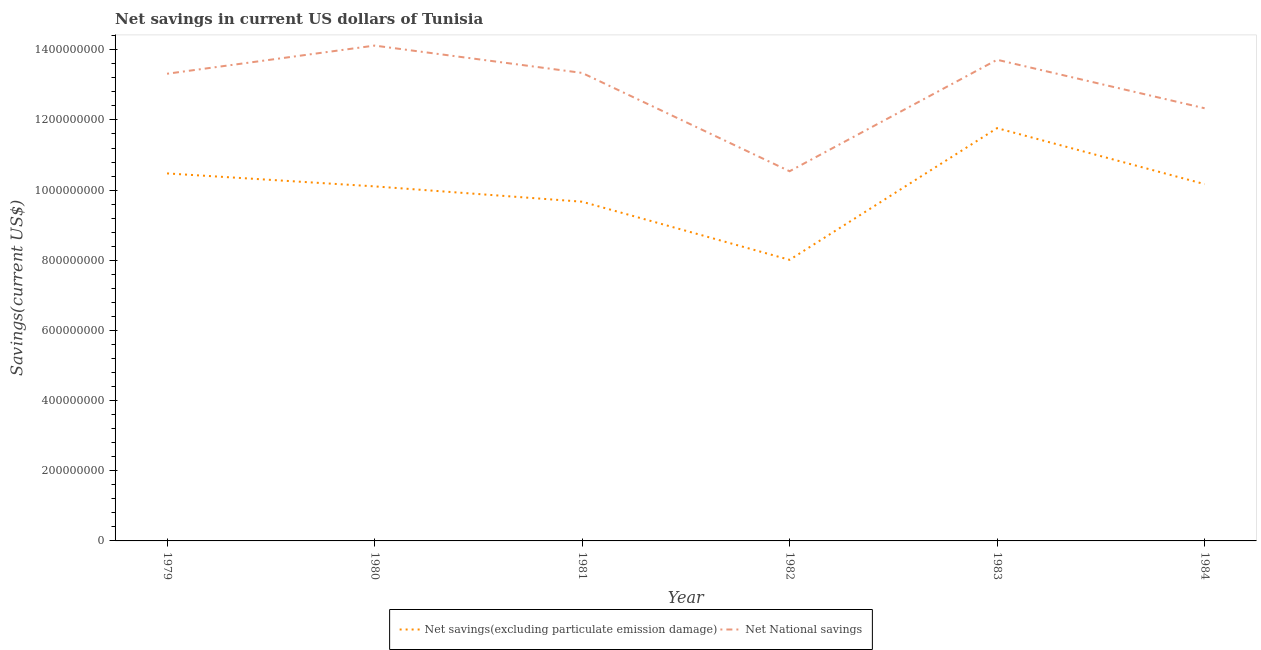How many different coloured lines are there?
Your answer should be very brief. 2. Is the number of lines equal to the number of legend labels?
Your answer should be very brief. Yes. What is the net savings(excluding particulate emission damage) in 1979?
Keep it short and to the point. 1.05e+09. Across all years, what is the maximum net savings(excluding particulate emission damage)?
Your response must be concise. 1.18e+09. Across all years, what is the minimum net national savings?
Make the answer very short. 1.05e+09. In which year was the net national savings maximum?
Ensure brevity in your answer.  1980. What is the total net national savings in the graph?
Provide a short and direct response. 7.74e+09. What is the difference between the net national savings in 1981 and that in 1984?
Offer a terse response. 1.01e+08. What is the difference between the net national savings in 1982 and the net savings(excluding particulate emission damage) in 1984?
Offer a terse response. 3.68e+07. What is the average net savings(excluding particulate emission damage) per year?
Your answer should be compact. 1.00e+09. In the year 1984, what is the difference between the net savings(excluding particulate emission damage) and net national savings?
Give a very brief answer. -2.16e+08. What is the ratio of the net savings(excluding particulate emission damage) in 1981 to that in 1984?
Ensure brevity in your answer.  0.95. Is the net savings(excluding particulate emission damage) in 1980 less than that in 1982?
Provide a succinct answer. No. Is the difference between the net savings(excluding particulate emission damage) in 1980 and 1982 greater than the difference between the net national savings in 1980 and 1982?
Keep it short and to the point. No. What is the difference between the highest and the second highest net national savings?
Your answer should be compact. 4.04e+07. What is the difference between the highest and the lowest net national savings?
Offer a very short reply. 3.58e+08. Is the net national savings strictly greater than the net savings(excluding particulate emission damage) over the years?
Provide a short and direct response. Yes. Is the net national savings strictly less than the net savings(excluding particulate emission damage) over the years?
Offer a terse response. No. How many lines are there?
Give a very brief answer. 2. How many years are there in the graph?
Keep it short and to the point. 6. What is the difference between two consecutive major ticks on the Y-axis?
Provide a succinct answer. 2.00e+08. Are the values on the major ticks of Y-axis written in scientific E-notation?
Your response must be concise. No. Does the graph contain any zero values?
Your answer should be very brief. No. Does the graph contain grids?
Your response must be concise. No. Where does the legend appear in the graph?
Offer a terse response. Bottom center. How are the legend labels stacked?
Offer a very short reply. Horizontal. What is the title of the graph?
Your response must be concise. Net savings in current US dollars of Tunisia. Does "Formally registered" appear as one of the legend labels in the graph?
Your answer should be very brief. No. What is the label or title of the Y-axis?
Offer a terse response. Savings(current US$). What is the Savings(current US$) of Net savings(excluding particulate emission damage) in 1979?
Make the answer very short. 1.05e+09. What is the Savings(current US$) of Net National savings in 1979?
Make the answer very short. 1.33e+09. What is the Savings(current US$) of Net savings(excluding particulate emission damage) in 1980?
Provide a succinct answer. 1.01e+09. What is the Savings(current US$) of Net National savings in 1980?
Keep it short and to the point. 1.41e+09. What is the Savings(current US$) of Net savings(excluding particulate emission damage) in 1981?
Your answer should be very brief. 9.67e+08. What is the Savings(current US$) in Net National savings in 1981?
Give a very brief answer. 1.33e+09. What is the Savings(current US$) in Net savings(excluding particulate emission damage) in 1982?
Ensure brevity in your answer.  8.01e+08. What is the Savings(current US$) of Net National savings in 1982?
Ensure brevity in your answer.  1.05e+09. What is the Savings(current US$) of Net savings(excluding particulate emission damage) in 1983?
Provide a short and direct response. 1.18e+09. What is the Savings(current US$) in Net National savings in 1983?
Offer a very short reply. 1.37e+09. What is the Savings(current US$) in Net savings(excluding particulate emission damage) in 1984?
Your answer should be very brief. 1.02e+09. What is the Savings(current US$) in Net National savings in 1984?
Ensure brevity in your answer.  1.23e+09. Across all years, what is the maximum Savings(current US$) in Net savings(excluding particulate emission damage)?
Your answer should be very brief. 1.18e+09. Across all years, what is the maximum Savings(current US$) in Net National savings?
Ensure brevity in your answer.  1.41e+09. Across all years, what is the minimum Savings(current US$) in Net savings(excluding particulate emission damage)?
Provide a succinct answer. 8.01e+08. Across all years, what is the minimum Savings(current US$) of Net National savings?
Your answer should be compact. 1.05e+09. What is the total Savings(current US$) of Net savings(excluding particulate emission damage) in the graph?
Your response must be concise. 6.02e+09. What is the total Savings(current US$) in Net National savings in the graph?
Provide a short and direct response. 7.74e+09. What is the difference between the Savings(current US$) in Net savings(excluding particulate emission damage) in 1979 and that in 1980?
Offer a very short reply. 3.70e+07. What is the difference between the Savings(current US$) in Net National savings in 1979 and that in 1980?
Offer a very short reply. -8.03e+07. What is the difference between the Savings(current US$) of Net savings(excluding particulate emission damage) in 1979 and that in 1981?
Give a very brief answer. 8.07e+07. What is the difference between the Savings(current US$) of Net National savings in 1979 and that in 1981?
Give a very brief answer. -2.39e+06. What is the difference between the Savings(current US$) of Net savings(excluding particulate emission damage) in 1979 and that in 1982?
Provide a short and direct response. 2.46e+08. What is the difference between the Savings(current US$) of Net National savings in 1979 and that in 1982?
Provide a short and direct response. 2.78e+08. What is the difference between the Savings(current US$) in Net savings(excluding particulate emission damage) in 1979 and that in 1983?
Your answer should be compact. -1.29e+08. What is the difference between the Savings(current US$) in Net National savings in 1979 and that in 1983?
Your answer should be very brief. -3.99e+07. What is the difference between the Savings(current US$) of Net savings(excluding particulate emission damage) in 1979 and that in 1984?
Ensure brevity in your answer.  3.06e+07. What is the difference between the Savings(current US$) in Net National savings in 1979 and that in 1984?
Offer a terse response. 9.84e+07. What is the difference between the Savings(current US$) of Net savings(excluding particulate emission damage) in 1980 and that in 1981?
Your answer should be very brief. 4.37e+07. What is the difference between the Savings(current US$) in Net National savings in 1980 and that in 1981?
Ensure brevity in your answer.  7.79e+07. What is the difference between the Savings(current US$) in Net savings(excluding particulate emission damage) in 1980 and that in 1982?
Provide a short and direct response. 2.09e+08. What is the difference between the Savings(current US$) of Net National savings in 1980 and that in 1982?
Offer a very short reply. 3.58e+08. What is the difference between the Savings(current US$) in Net savings(excluding particulate emission damage) in 1980 and that in 1983?
Provide a short and direct response. -1.66e+08. What is the difference between the Savings(current US$) of Net National savings in 1980 and that in 1983?
Offer a terse response. 4.04e+07. What is the difference between the Savings(current US$) in Net savings(excluding particulate emission damage) in 1980 and that in 1984?
Provide a succinct answer. -6.39e+06. What is the difference between the Savings(current US$) of Net National savings in 1980 and that in 1984?
Provide a short and direct response. 1.79e+08. What is the difference between the Savings(current US$) in Net savings(excluding particulate emission damage) in 1981 and that in 1982?
Offer a very short reply. 1.66e+08. What is the difference between the Savings(current US$) in Net National savings in 1981 and that in 1982?
Give a very brief answer. 2.80e+08. What is the difference between the Savings(current US$) in Net savings(excluding particulate emission damage) in 1981 and that in 1983?
Your answer should be compact. -2.10e+08. What is the difference between the Savings(current US$) in Net National savings in 1981 and that in 1983?
Make the answer very short. -3.75e+07. What is the difference between the Savings(current US$) in Net savings(excluding particulate emission damage) in 1981 and that in 1984?
Offer a very short reply. -5.01e+07. What is the difference between the Savings(current US$) in Net National savings in 1981 and that in 1984?
Your answer should be compact. 1.01e+08. What is the difference between the Savings(current US$) in Net savings(excluding particulate emission damage) in 1982 and that in 1983?
Keep it short and to the point. -3.75e+08. What is the difference between the Savings(current US$) in Net National savings in 1982 and that in 1983?
Offer a very short reply. -3.18e+08. What is the difference between the Savings(current US$) of Net savings(excluding particulate emission damage) in 1982 and that in 1984?
Offer a very short reply. -2.16e+08. What is the difference between the Savings(current US$) of Net National savings in 1982 and that in 1984?
Make the answer very short. -1.80e+08. What is the difference between the Savings(current US$) of Net savings(excluding particulate emission damage) in 1983 and that in 1984?
Provide a succinct answer. 1.60e+08. What is the difference between the Savings(current US$) of Net National savings in 1983 and that in 1984?
Your answer should be compact. 1.38e+08. What is the difference between the Savings(current US$) of Net savings(excluding particulate emission damage) in 1979 and the Savings(current US$) of Net National savings in 1980?
Provide a succinct answer. -3.64e+08. What is the difference between the Savings(current US$) of Net savings(excluding particulate emission damage) in 1979 and the Savings(current US$) of Net National savings in 1981?
Your response must be concise. -2.86e+08. What is the difference between the Savings(current US$) in Net savings(excluding particulate emission damage) in 1979 and the Savings(current US$) in Net National savings in 1982?
Provide a short and direct response. -6.18e+06. What is the difference between the Savings(current US$) in Net savings(excluding particulate emission damage) in 1979 and the Savings(current US$) in Net National savings in 1983?
Keep it short and to the point. -3.24e+08. What is the difference between the Savings(current US$) in Net savings(excluding particulate emission damage) in 1979 and the Savings(current US$) in Net National savings in 1984?
Offer a very short reply. -1.86e+08. What is the difference between the Savings(current US$) in Net savings(excluding particulate emission damage) in 1980 and the Savings(current US$) in Net National savings in 1981?
Offer a very short reply. -3.23e+08. What is the difference between the Savings(current US$) in Net savings(excluding particulate emission damage) in 1980 and the Savings(current US$) in Net National savings in 1982?
Give a very brief answer. -4.31e+07. What is the difference between the Savings(current US$) in Net savings(excluding particulate emission damage) in 1980 and the Savings(current US$) in Net National savings in 1983?
Provide a short and direct response. -3.61e+08. What is the difference between the Savings(current US$) in Net savings(excluding particulate emission damage) in 1980 and the Savings(current US$) in Net National savings in 1984?
Keep it short and to the point. -2.23e+08. What is the difference between the Savings(current US$) of Net savings(excluding particulate emission damage) in 1981 and the Savings(current US$) of Net National savings in 1982?
Your answer should be very brief. -8.69e+07. What is the difference between the Savings(current US$) in Net savings(excluding particulate emission damage) in 1981 and the Savings(current US$) in Net National savings in 1983?
Offer a terse response. -4.05e+08. What is the difference between the Savings(current US$) in Net savings(excluding particulate emission damage) in 1981 and the Savings(current US$) in Net National savings in 1984?
Provide a short and direct response. -2.66e+08. What is the difference between the Savings(current US$) in Net savings(excluding particulate emission damage) in 1982 and the Savings(current US$) in Net National savings in 1983?
Give a very brief answer. -5.70e+08. What is the difference between the Savings(current US$) in Net savings(excluding particulate emission damage) in 1982 and the Savings(current US$) in Net National savings in 1984?
Give a very brief answer. -4.32e+08. What is the difference between the Savings(current US$) in Net savings(excluding particulate emission damage) in 1983 and the Savings(current US$) in Net National savings in 1984?
Give a very brief answer. -5.67e+07. What is the average Savings(current US$) in Net savings(excluding particulate emission damage) per year?
Your answer should be compact. 1.00e+09. What is the average Savings(current US$) of Net National savings per year?
Ensure brevity in your answer.  1.29e+09. In the year 1979, what is the difference between the Savings(current US$) of Net savings(excluding particulate emission damage) and Savings(current US$) of Net National savings?
Your response must be concise. -2.84e+08. In the year 1980, what is the difference between the Savings(current US$) in Net savings(excluding particulate emission damage) and Savings(current US$) in Net National savings?
Your answer should be very brief. -4.01e+08. In the year 1981, what is the difference between the Savings(current US$) of Net savings(excluding particulate emission damage) and Savings(current US$) of Net National savings?
Give a very brief answer. -3.67e+08. In the year 1982, what is the difference between the Savings(current US$) of Net savings(excluding particulate emission damage) and Savings(current US$) of Net National savings?
Make the answer very short. -2.53e+08. In the year 1983, what is the difference between the Savings(current US$) in Net savings(excluding particulate emission damage) and Savings(current US$) in Net National savings?
Make the answer very short. -1.95e+08. In the year 1984, what is the difference between the Savings(current US$) of Net savings(excluding particulate emission damage) and Savings(current US$) of Net National savings?
Your answer should be very brief. -2.16e+08. What is the ratio of the Savings(current US$) in Net savings(excluding particulate emission damage) in 1979 to that in 1980?
Your answer should be compact. 1.04. What is the ratio of the Savings(current US$) of Net National savings in 1979 to that in 1980?
Make the answer very short. 0.94. What is the ratio of the Savings(current US$) of Net savings(excluding particulate emission damage) in 1979 to that in 1981?
Ensure brevity in your answer.  1.08. What is the ratio of the Savings(current US$) of Net savings(excluding particulate emission damage) in 1979 to that in 1982?
Offer a very short reply. 1.31. What is the ratio of the Savings(current US$) of Net National savings in 1979 to that in 1982?
Make the answer very short. 1.26. What is the ratio of the Savings(current US$) of Net savings(excluding particulate emission damage) in 1979 to that in 1983?
Your answer should be very brief. 0.89. What is the ratio of the Savings(current US$) in Net National savings in 1979 to that in 1983?
Provide a succinct answer. 0.97. What is the ratio of the Savings(current US$) of Net savings(excluding particulate emission damage) in 1979 to that in 1984?
Provide a succinct answer. 1.03. What is the ratio of the Savings(current US$) in Net National savings in 1979 to that in 1984?
Offer a terse response. 1.08. What is the ratio of the Savings(current US$) in Net savings(excluding particulate emission damage) in 1980 to that in 1981?
Keep it short and to the point. 1.05. What is the ratio of the Savings(current US$) in Net National savings in 1980 to that in 1981?
Offer a very short reply. 1.06. What is the ratio of the Savings(current US$) of Net savings(excluding particulate emission damage) in 1980 to that in 1982?
Make the answer very short. 1.26. What is the ratio of the Savings(current US$) in Net National savings in 1980 to that in 1982?
Your answer should be compact. 1.34. What is the ratio of the Savings(current US$) in Net savings(excluding particulate emission damage) in 1980 to that in 1983?
Offer a terse response. 0.86. What is the ratio of the Savings(current US$) in Net National savings in 1980 to that in 1983?
Offer a terse response. 1.03. What is the ratio of the Savings(current US$) in Net savings(excluding particulate emission damage) in 1980 to that in 1984?
Provide a succinct answer. 0.99. What is the ratio of the Savings(current US$) in Net National savings in 1980 to that in 1984?
Make the answer very short. 1.14. What is the ratio of the Savings(current US$) in Net savings(excluding particulate emission damage) in 1981 to that in 1982?
Offer a very short reply. 1.21. What is the ratio of the Savings(current US$) in Net National savings in 1981 to that in 1982?
Ensure brevity in your answer.  1.27. What is the ratio of the Savings(current US$) of Net savings(excluding particulate emission damage) in 1981 to that in 1983?
Provide a succinct answer. 0.82. What is the ratio of the Savings(current US$) of Net National savings in 1981 to that in 1983?
Provide a short and direct response. 0.97. What is the ratio of the Savings(current US$) in Net savings(excluding particulate emission damage) in 1981 to that in 1984?
Your answer should be compact. 0.95. What is the ratio of the Savings(current US$) of Net National savings in 1981 to that in 1984?
Provide a short and direct response. 1.08. What is the ratio of the Savings(current US$) in Net savings(excluding particulate emission damage) in 1982 to that in 1983?
Offer a terse response. 0.68. What is the ratio of the Savings(current US$) in Net National savings in 1982 to that in 1983?
Your answer should be very brief. 0.77. What is the ratio of the Savings(current US$) in Net savings(excluding particulate emission damage) in 1982 to that in 1984?
Your response must be concise. 0.79. What is the ratio of the Savings(current US$) in Net National savings in 1982 to that in 1984?
Make the answer very short. 0.85. What is the ratio of the Savings(current US$) of Net savings(excluding particulate emission damage) in 1983 to that in 1984?
Your response must be concise. 1.16. What is the ratio of the Savings(current US$) of Net National savings in 1983 to that in 1984?
Ensure brevity in your answer.  1.11. What is the difference between the highest and the second highest Savings(current US$) in Net savings(excluding particulate emission damage)?
Offer a terse response. 1.29e+08. What is the difference between the highest and the second highest Savings(current US$) of Net National savings?
Make the answer very short. 4.04e+07. What is the difference between the highest and the lowest Savings(current US$) in Net savings(excluding particulate emission damage)?
Your response must be concise. 3.75e+08. What is the difference between the highest and the lowest Savings(current US$) of Net National savings?
Your response must be concise. 3.58e+08. 